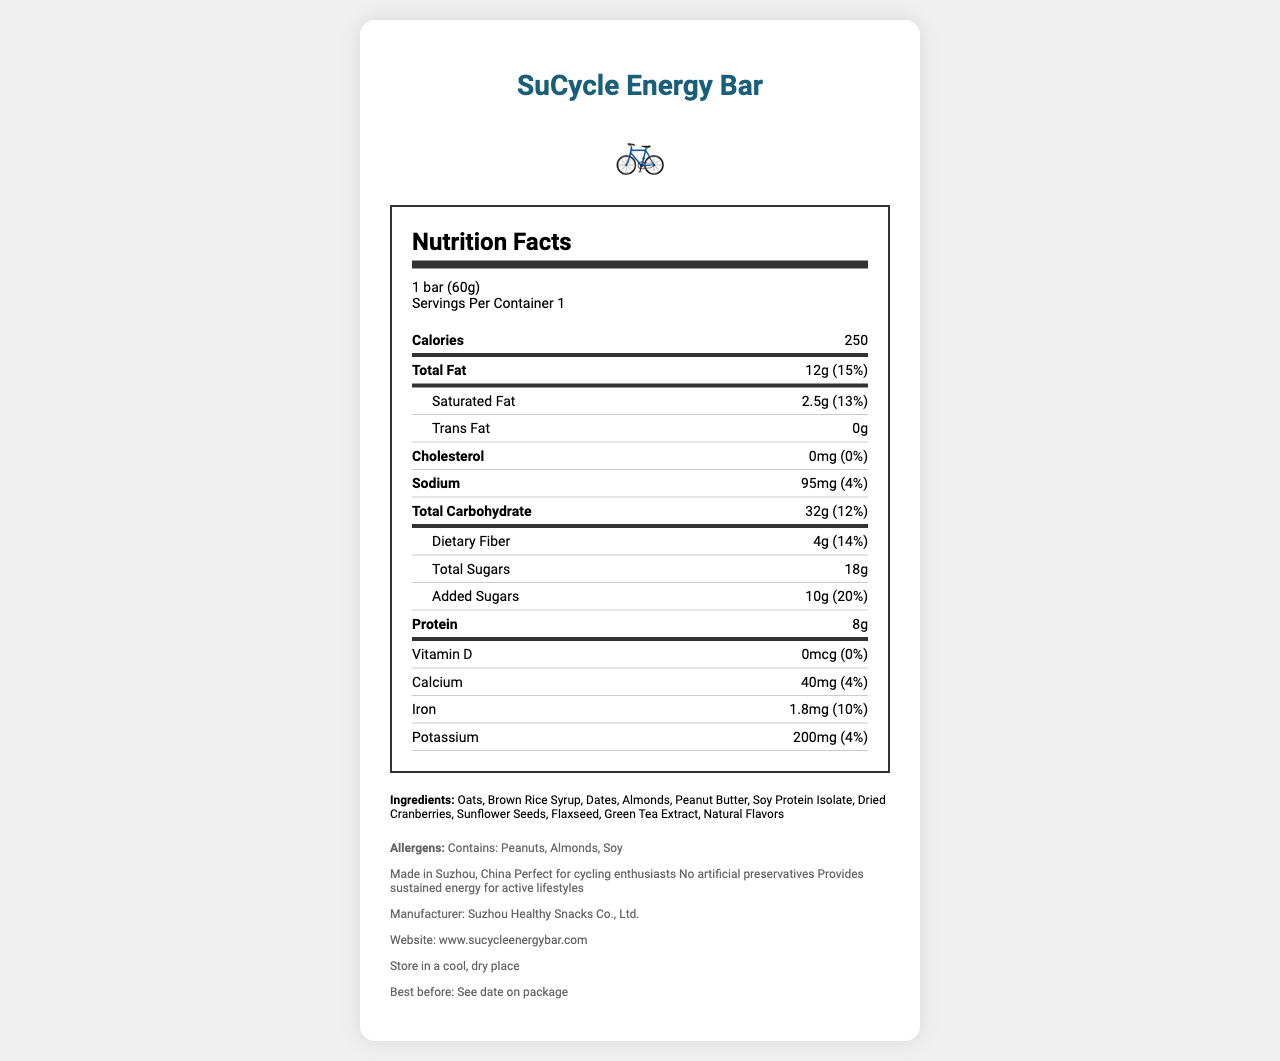what is the serving size? The serving size is specified at the beginning of the nutrition facts section as "1 bar (60g)".
Answer: 1 bar (60g) how many calories are in one serving? The calories per serving are listed in the thick-line section under Calories as "250".
Answer: 250 what percentage of daily value of total fat does one serving of the bar contain? The percentage of daily value for total fat is listed next to the total fat amount as "15%".
Answer: 15% what are the main ingredients of the SuCycle Energy Bar? The ingredients are listed under the Ingredients section.
Answer: Oats, Brown Rice Syrup, Dates, Almonds, Peanut Butter, Soy Protein Isolate, Dried Cranberries, Sunflower Seeds, Flaxseed, Green Tea Extract, Natural Flavors how much protein is in one serving? The protein content per serving is specified in the thick-line section under Protein as "8g".
Answer: 8g how much calcium does one bar contain? A. 20mg B. 30mg C. 40mg D. 50mg The amount of calcium per bar is listed under Calcium as "40mg".
Answer: C. 40mg what is the amount of dietary fiber in one serving? A. 2g B. 4g C. 6g D. 8g The amount of dietary fiber is listed with the total carbohydrate information as "4g".
Answer: B. 4g does the SuCycle Energy Bar contain any trans fat? The trans fat content is listed as "0g".
Answer: No is the SuCycle Energy Bar suitable for people with peanut allergies? The bar contains peanuts as listed in the allergens section: "Contains: Peanuts, Almonds, Soy".
Answer: No Briefly summarize the Nutrition Facts Label of the SuCycle Energy Bar. This summary covers the key points about serving size, nutritional content, ingredients, allergens, and additional information relevant to the document.
Answer: The SuCycle Energy Bar provides nutritional information for a single serving of 1 bar (60g), with 250 calories. It includes details on macronutrients like fats, carbohydrates, and proteins, along with specific amounts of vitamins and minerals. The bar contains no trans fat or cholesterol and provides dietary fiber and various sugars. Ingredients and allergens are also listed. It's specifically designed for active lifestyles and marketed towards cycling enthusiasts, made in Suzhou, China. What is the expiration date of the SuCycle Energy Bar? The document states "Best before: See date on package," but the actual expiration date is not provided in the document.
Answer: Cannot be determined Who is the manufacturer of the SuCycle Energy Bar? The manufacturer is listed in the additional information section as "Suzhou Healthy Snacks Co., Ltd."
Answer: Suzhou Healthy Snacks Co., Ltd. What is the website for more information about the SuCycle Energy Bar? The website is provided in the additional information section as "www.sucycleenergybar.com."
Answer: www.sucycleenergybar.com Can the bar be stored in a humid place? The storage instructions specify "Store in a cool, dry place."
Answer: No 